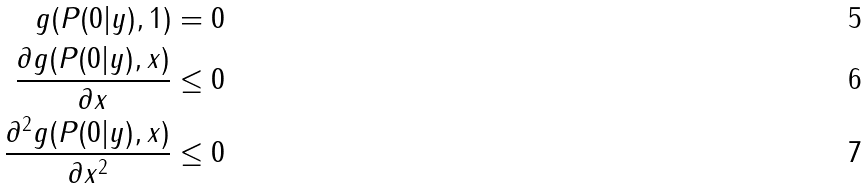<formula> <loc_0><loc_0><loc_500><loc_500>g ( P ( 0 | y ) , 1 ) & = 0 \\ \frac { \partial g ( P ( 0 | y ) , x ) } { \partial x } & \leq 0 \\ \frac { \partial ^ { 2 } g ( P ( 0 | y ) , x ) } { \partial x ^ { 2 } } & \leq 0</formula> 